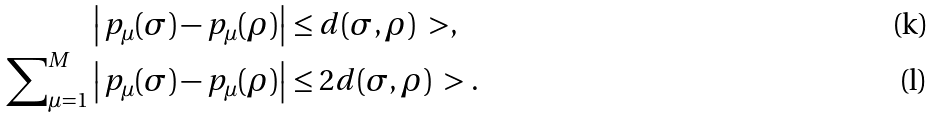<formula> <loc_0><loc_0><loc_500><loc_500>& \left | \, p _ { \mu } ( \sigma ) - p _ { \mu } ( \rho ) \right | \leq d ( \sigma , \rho ) \ > , \\ \sum \nolimits _ { \mu = 1 } ^ { M } & \left | \, p _ { \mu } ( \sigma ) - p _ { \mu } ( \rho ) \right | \leq 2 d ( \sigma , \rho ) \ > .</formula> 